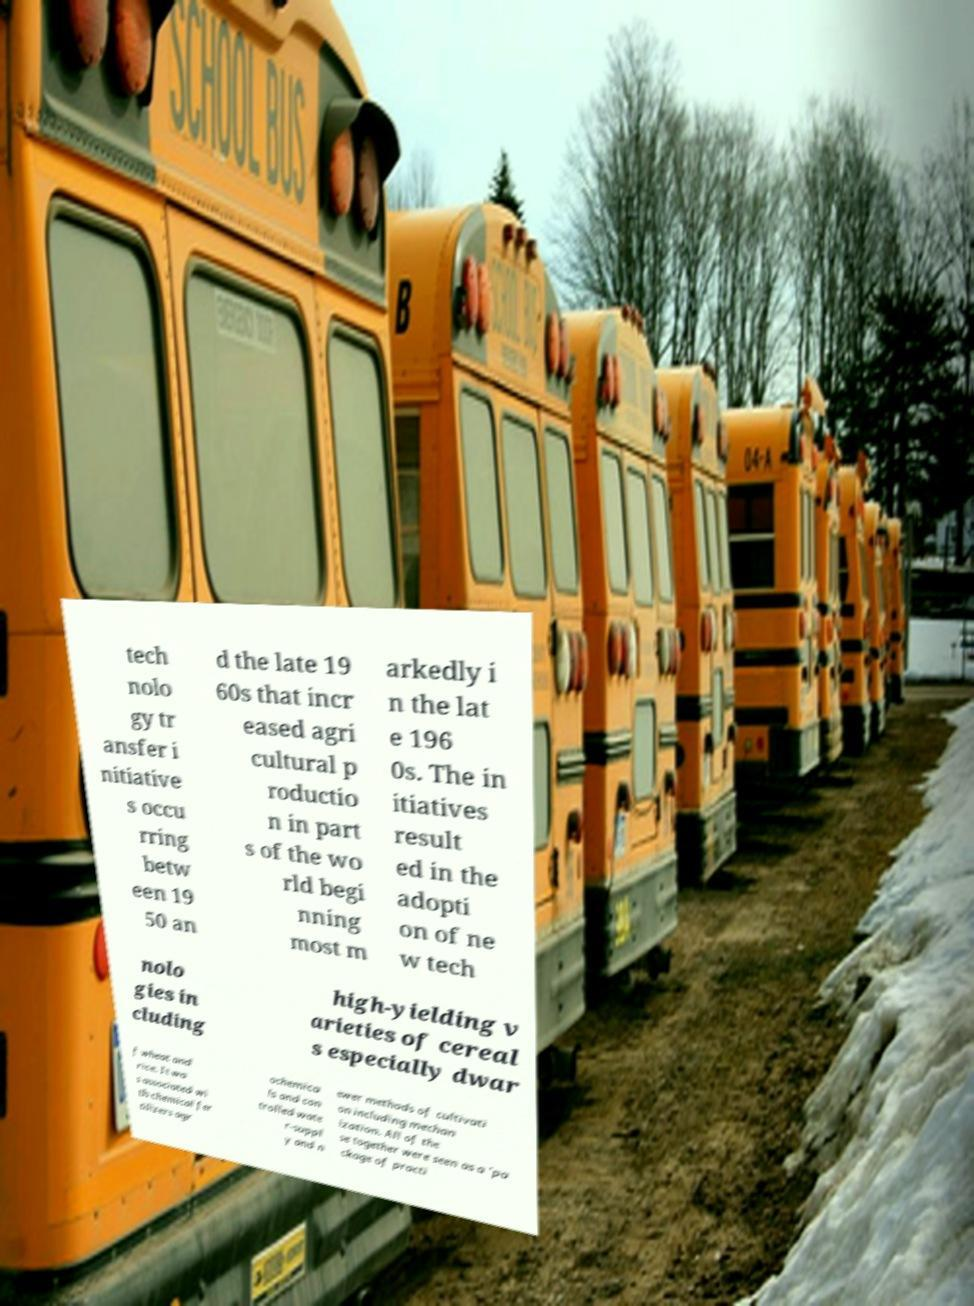Please read and relay the text visible in this image. What does it say? tech nolo gy tr ansfer i nitiative s occu rring betw een 19 50 an d the late 19 60s that incr eased agri cultural p roductio n in part s of the wo rld begi nning most m arkedly i n the lat e 196 0s. The in itiatives result ed in the adopti on of ne w tech nolo gies in cluding high-yielding v arieties of cereal s especially dwar f wheat and rice. It wa s associated wi th chemical fer tilizers agr ochemica ls and con trolled wate r-suppl y and n ewer methods of cultivati on including mechan ization. All of the se together were seen as a 'pa ckage of practi 